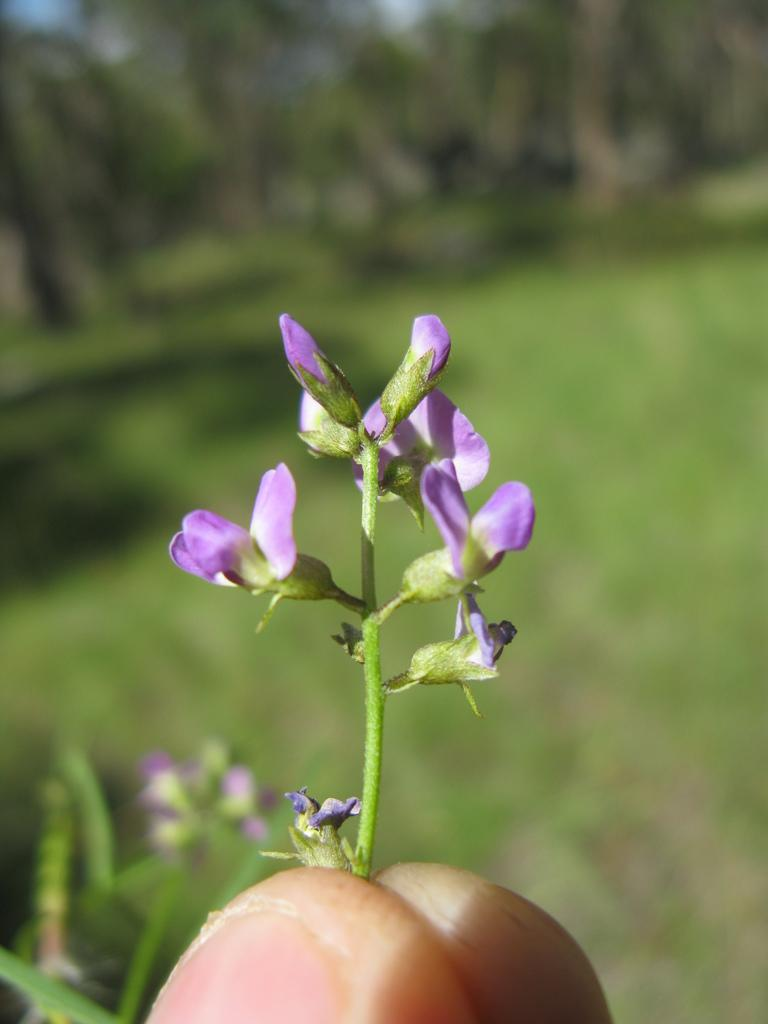Who or what is the main subject in the image? There is a person in the image. What is the person holding in the image? The person is holding flowers. Can you describe the color of the flowers? The flowers are purple. What can be seen in the background of the image? There are plants in the background of the image. How would you describe the background's appearance? The background of the image is blurred. What type of chalk is the person using to write a prose on the team's whiteboard in the image? There is no chalk, prose, or team present in the image. 